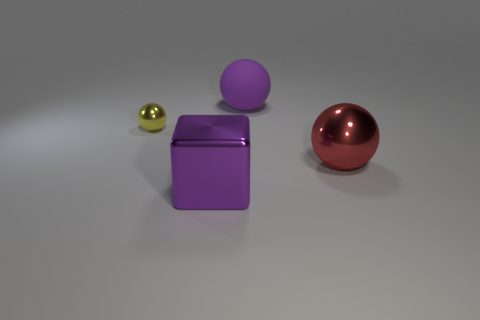How many balls are left of the large thing behind the tiny shiny thing?
Ensure brevity in your answer.  1. Is the number of matte objects that are on the left side of the big matte sphere less than the number of yellow rubber blocks?
Offer a terse response. No. There is a purple object behind the large object to the left of the purple rubber thing; are there any purple blocks in front of it?
Provide a short and direct response. Yes. Is the material of the big red thing the same as the ball that is left of the large purple block?
Provide a succinct answer. Yes. The big metallic thing that is behind the purple object that is in front of the large metallic ball is what color?
Provide a succinct answer. Red. Is there a big matte sphere of the same color as the metallic block?
Your answer should be very brief. Yes. What size is the red thing that is in front of the big thing behind the shiny ball that is on the right side of the large matte ball?
Ensure brevity in your answer.  Large. There is a big red metallic thing; is it the same shape as the thing on the left side of the block?
Give a very brief answer. Yes. What number of other things are there of the same size as the rubber thing?
Your answer should be very brief. 2. What size is the metal ball that is to the left of the matte object?
Ensure brevity in your answer.  Small. 